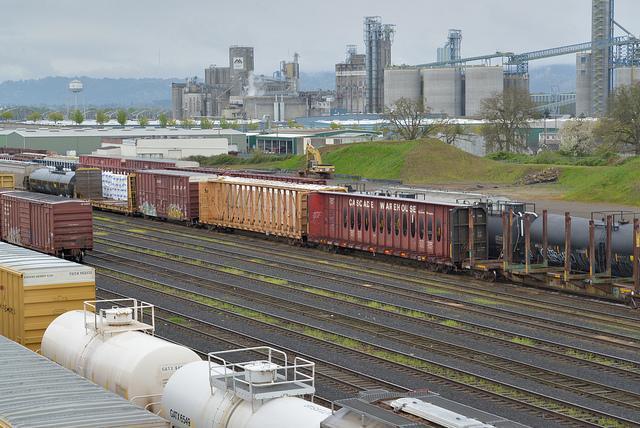How many trains are there?
Give a very brief answer. 3. How many people are in the carriage?
Give a very brief answer. 0. 